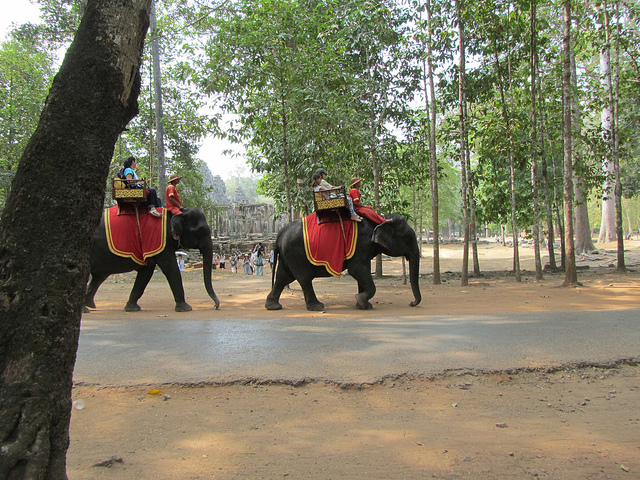What is the location depicted in the image? The image appears to show a path lined with trees, and the architecture in the background resembles the style of ancient Cambodian temples, indicating that it could be the historical site of Angkor Wat. 